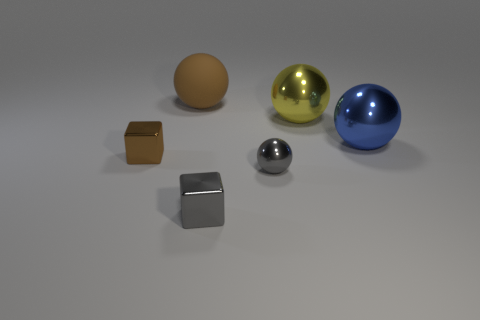What is the size of the metal object that is both on the left side of the tiny gray metallic sphere and behind the tiny ball? The size of the metal object, positioned to the left of the small gray metallic sphere and behind the small ball, appears to be moderately small. To be more specific, it is relatively larger than the tiny metallic sphere but significantly smaller than the other surrounding objects, like the golden and blue spheres. 